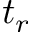<formula> <loc_0><loc_0><loc_500><loc_500>t _ { r }</formula> 